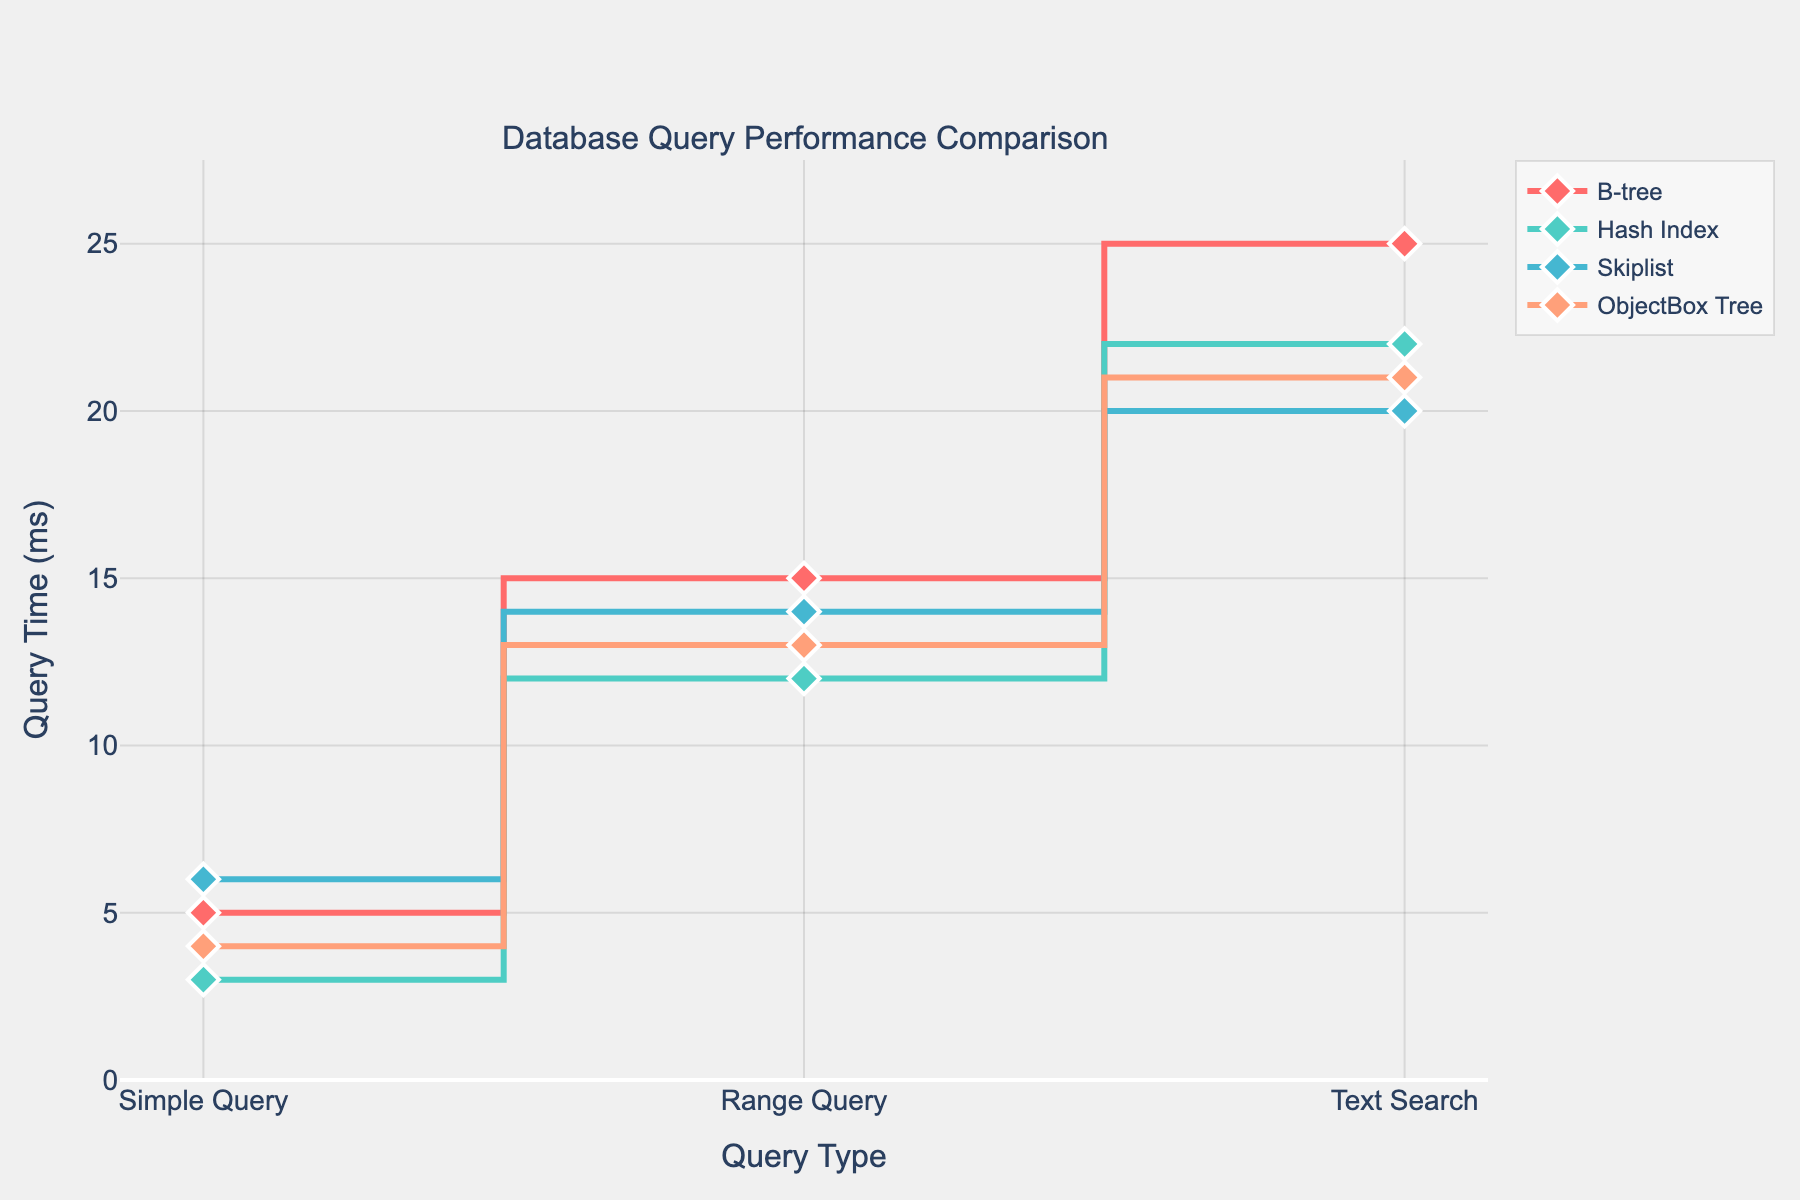What's the title of the figure? The title is placed at the top of the figure. By reading the text in the title, you can determine it.
Answer: Database Query Performance Comparison How many different indexing strategies are compared in the figure? Each line represents an indexing strategy. Count the number of distinct lines or strategies listed in the legend.
Answer: 4 Which query type has the highest query time overall? Look at all the query times for each query type and identify which type has the highest value across all strategies.
Answer: Text Search What is the query time for the Range Query using ObjectBox Tree? Find the ObjectBox Tree trace in the figure and identify the value corresponding to the Range Query on the x-axis.
Answer: 13 ms Which indexing strategy has the fastest Simple Query performance? Compare the Simple Query values for all strategies and find the one with the lowest value.
Answer: Hash Index What is the difference in query time between the Simple Query and Text Search for B-tree? Locate the values for Simple Query and Text Search for B-tree, then subtract the Simple Query time from the Text Search time.
Answer: 20 ms On average, which indexing strategy performs best for Range Query? Calculate the average query time for the Range Query across all strategies and determine the one with the lowest average time.
Answer: Hash Index Which indexing strategy shows the most consistent performance across all query types (smallest difference between max and min query time)? For each strategy, calculate the difference between the highest and lowest query times across the three query types. Identify the strategy with the smallest difference.
Answer: Skiplist How does the performance of the Skiplist compare to ObjectBox Tree for the Text Search? Compare the Text Search values for both Skiplist and ObjectBox Tree by subtracting one from the other.
Answer: Skiplist is 1 ms faster 